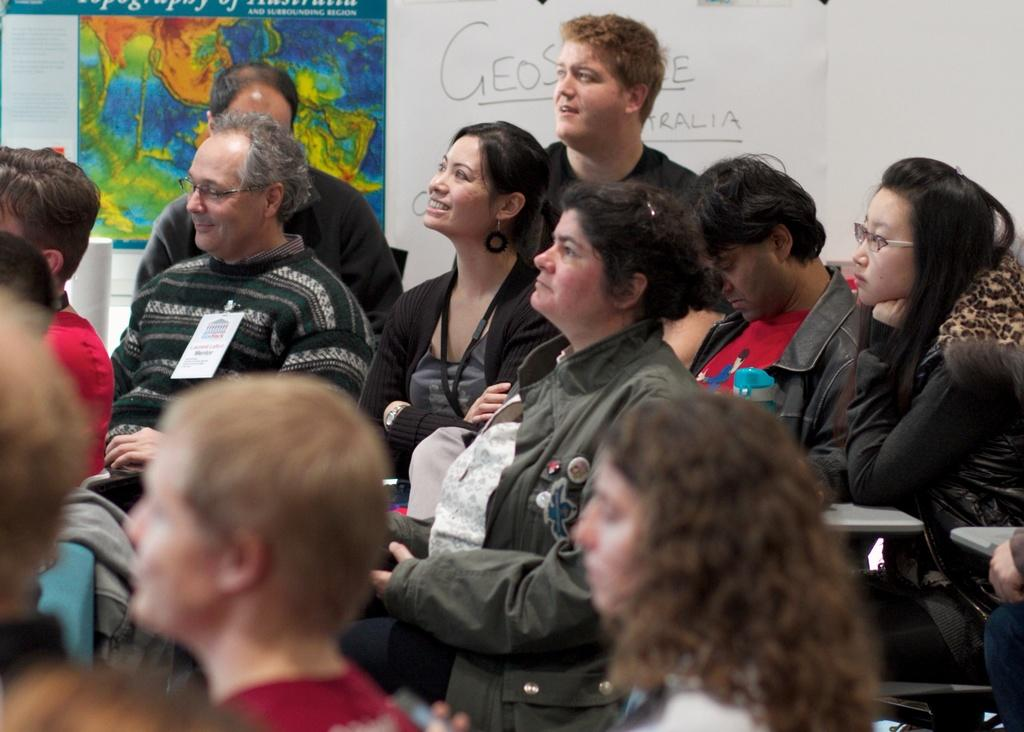What are the people in the image doing? The people in the image are sitting on chairs. Is there any issue with the clarity of the image? Yes, the image is slightly blurred in that area. What can be seen on the wall in the background of the image? There are posters on the wall in the background of the image. What type of driving is being discussed at the meeting in the image? There is no meeting or driving present in the image; it features people sitting on chairs with posters on the wall in the background. What is the condition of the neck of the person sitting on the chair in the image? There is no information about the neck of the person sitting on the chair in the image. 